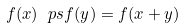Convert formula to latex. <formula><loc_0><loc_0><loc_500><loc_500>f ( x ) \ p s f ( y ) = f ( x + y )</formula> 